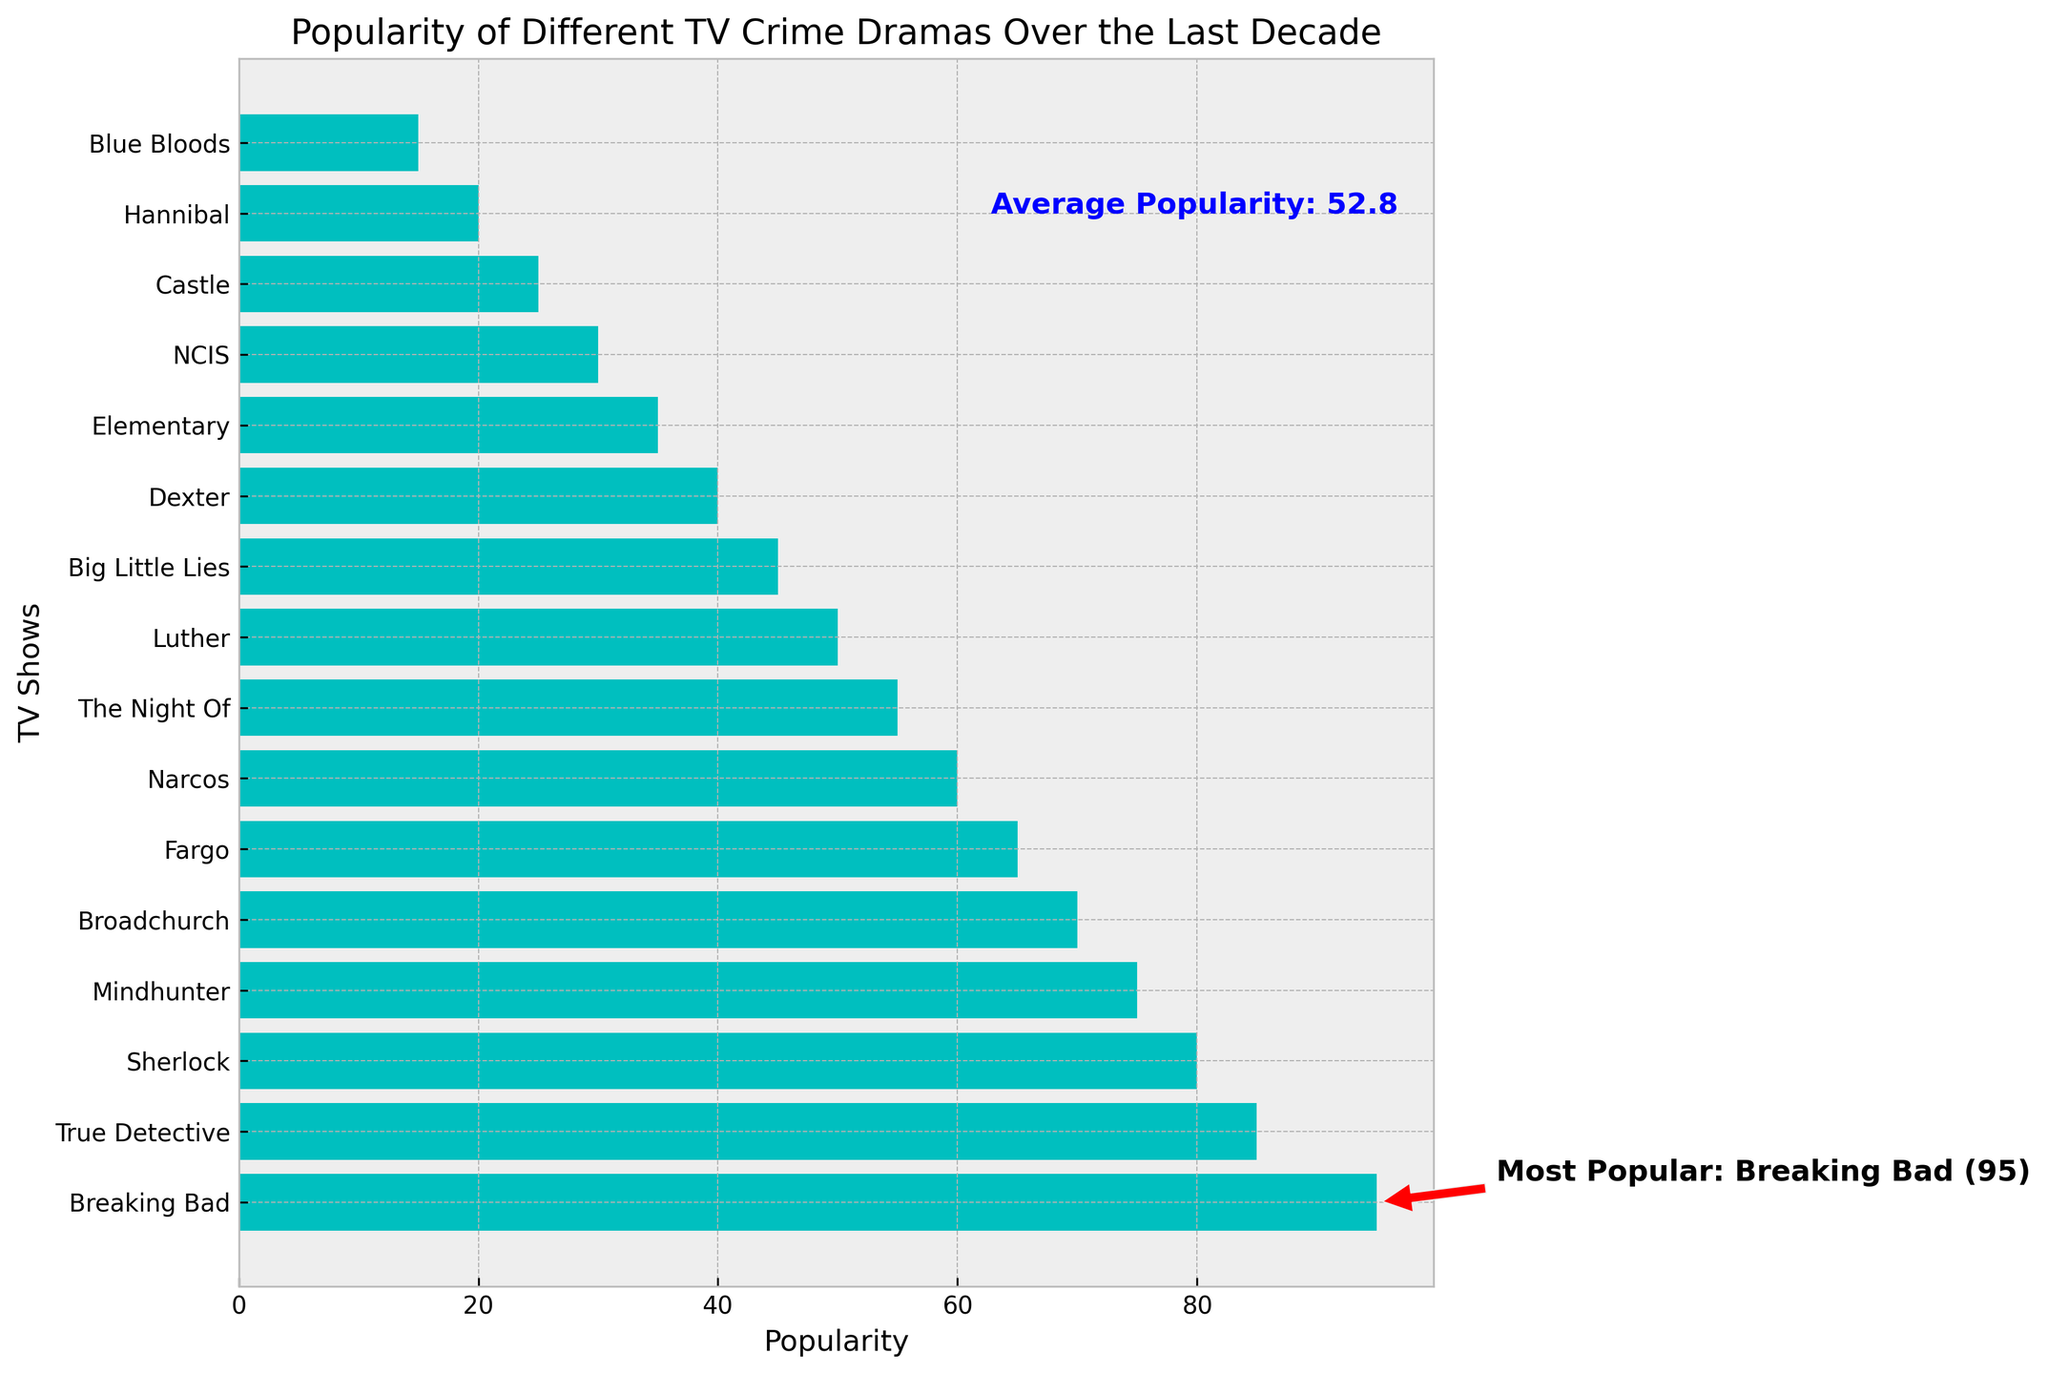Which TV show is the most popular? The annotation on the chart indicates that “Breaking Bad” is the most popular show with a popularity score of 95.
Answer: Breaking Bad What is the average popularity of the TV shows? The annotation on the chart states that the average popularity is 54.5.
Answer: 54.5 How much more popular is "Breaking Bad" compared to "Hannibal"? "Breaking Bad" has a popularity score of 95, while "Hannibal" has a popularity score of 20. The difference is 95 - 20 = 75.
Answer: 75 Is the popularity of "Sherlock" above or below the average popularity? According to the chart, "Sherlock" has a popularity score of 80, which is above the annotated average of 54.5.
Answer: Above Which shows have a popularity score below 50? From the chart, the shows below 50 are "Luther," "Big Little Lies," "Dexter," "Elementary," "NCIS," "Castle," "Hannibal," and "Blue Bloods."
Answer: Luther, Big Little Lies, Dexter, Elementary, NCIS, Castle, Hannibal, Blue Bloods What is the difference in popularity between "True Detective" and "Mindhunter"? "True Detective" has a popularity score of 85 and "Mindhunter" has a score of 75. The difference is 85 - 75 = 10.
Answer: 10 Which show has a popularity closest to the annotated average popularity? "The Night Of" has a popularity score of 55, which is closest to the annotated average of 54.5.
Answer: The Night Of How many shows have a popularity greater than "Narcos"? "Narcos" has a popularity score of 60. The shows with higher popularity are "Breaking Bad," "True Detective," "Sherlock," "Mindhunter," "Broadchurch," and "Fargo," totaling 6 shows.
Answer: 6 What is the range of the popularity scores in the chart? The highest popularity score is for "Breaking Bad" with 95, and the lowest is for "Blue Bloods" with 15. The range is 95 - 15 = 80.
Answer: 80 